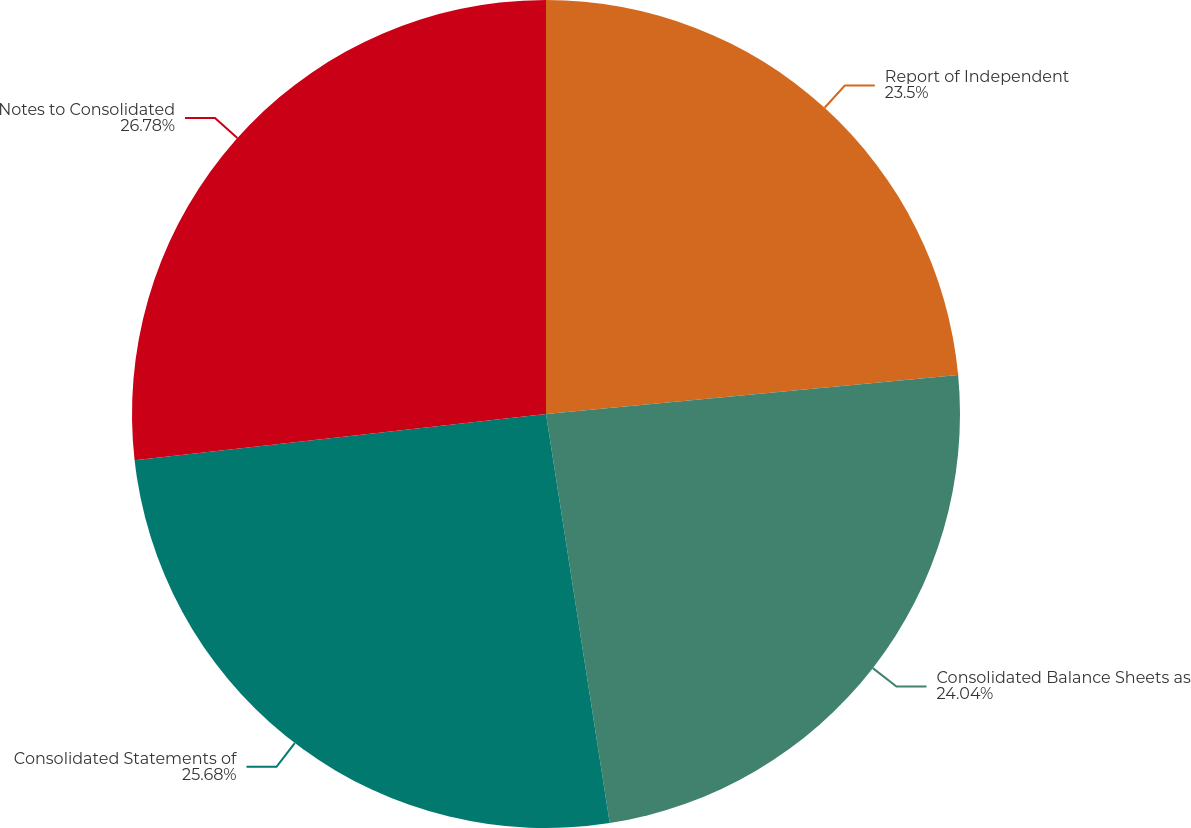Convert chart to OTSL. <chart><loc_0><loc_0><loc_500><loc_500><pie_chart><fcel>Report of Independent<fcel>Consolidated Balance Sheets as<fcel>Consolidated Statements of<fcel>Notes to Consolidated<nl><fcel>23.5%<fcel>24.04%<fcel>25.68%<fcel>26.78%<nl></chart> 